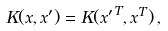Convert formula to latex. <formula><loc_0><loc_0><loc_500><loc_500>K ( { x } , { x ^ { \prime } } ) = K ( { x ^ { \prime } } ^ { T } , { x } ^ { T } ) \, ,</formula> 